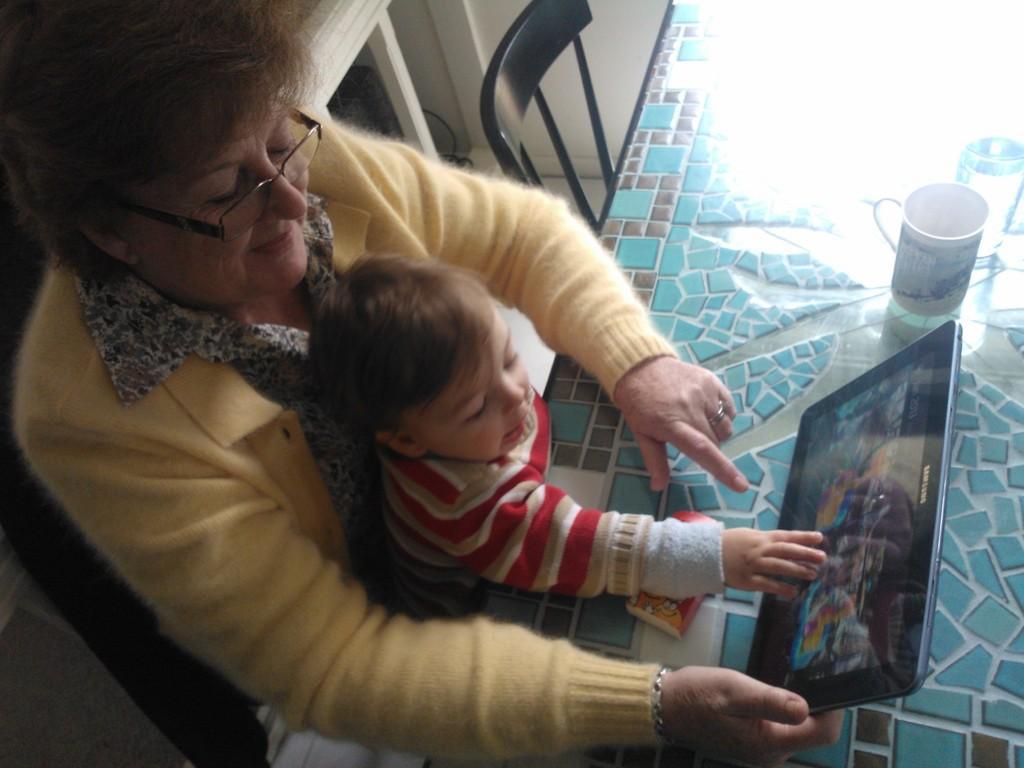Describe this image in one or two sentences. In this image we can see few people. A lady is holding an electronic gadget in her hand. There are few objects on the table. There is a chair at the top of the image. 